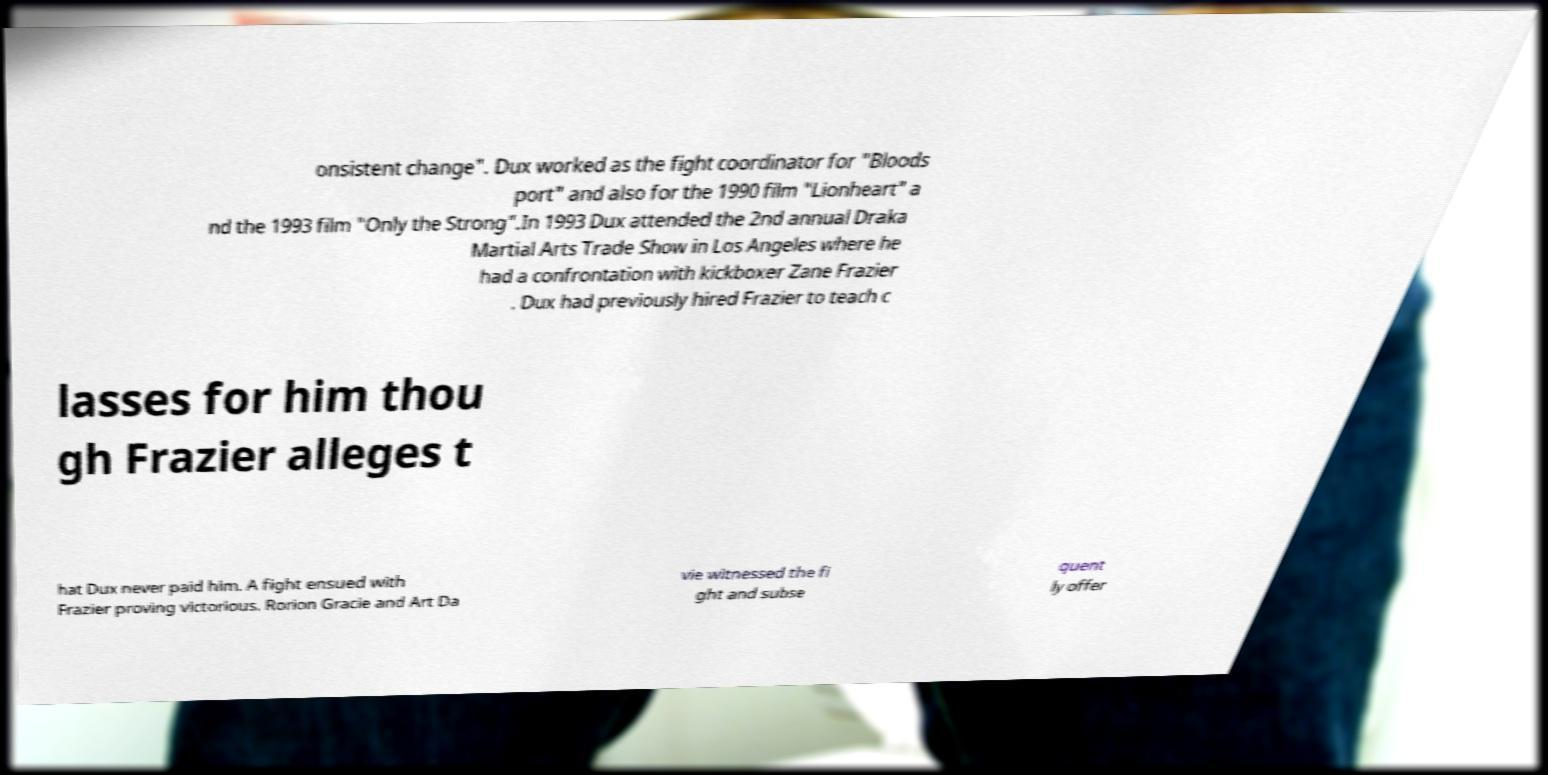What messages or text are displayed in this image? I need them in a readable, typed format. onsistent change". Dux worked as the fight coordinator for "Bloods port" and also for the 1990 film "Lionheart" a nd the 1993 film "Only the Strong".In 1993 Dux attended the 2nd annual Draka Martial Arts Trade Show in Los Angeles where he had a confrontation with kickboxer Zane Frazier . Dux had previously hired Frazier to teach c lasses for him thou gh Frazier alleges t hat Dux never paid him. A fight ensued with Frazier proving victorious. Rorion Gracie and Art Da vie witnessed the fi ght and subse quent ly offer 